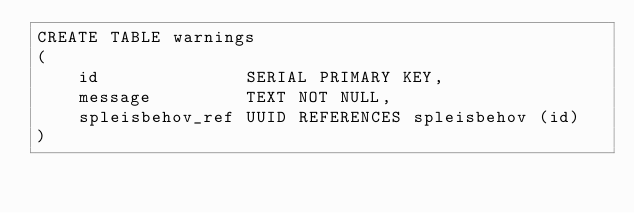Convert code to text. <code><loc_0><loc_0><loc_500><loc_500><_SQL_>CREATE TABLE warnings
(
    id              SERIAL PRIMARY KEY,
    message         TEXT NOT NULL,
    spleisbehov_ref UUID REFERENCES spleisbehov (id)
)
</code> 